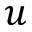Convert formula to latex. <formula><loc_0><loc_0><loc_500><loc_500>u</formula> 